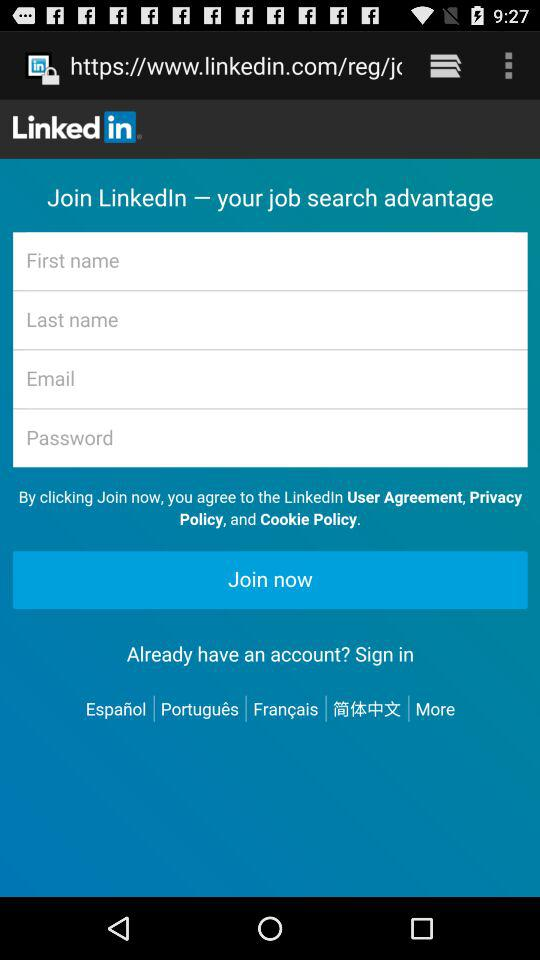What is the app name? The app name is "LinkedIn". 